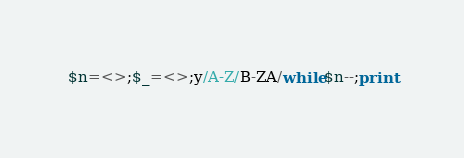<code> <loc_0><loc_0><loc_500><loc_500><_Perl_>$n=<>;$_=<>;y/A-Z/B-ZA/while$n--;print</code> 